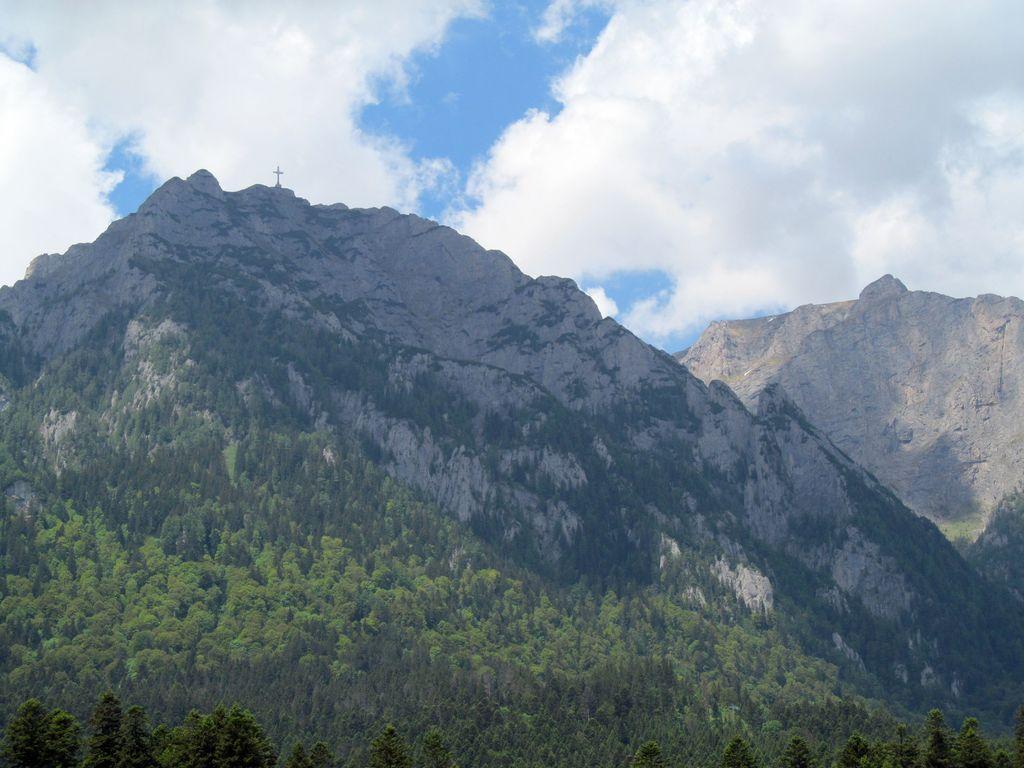Please provide a concise description of this image. In this image in the foreground there are trees. In the background there are mountains. There are clouds in the sky. 